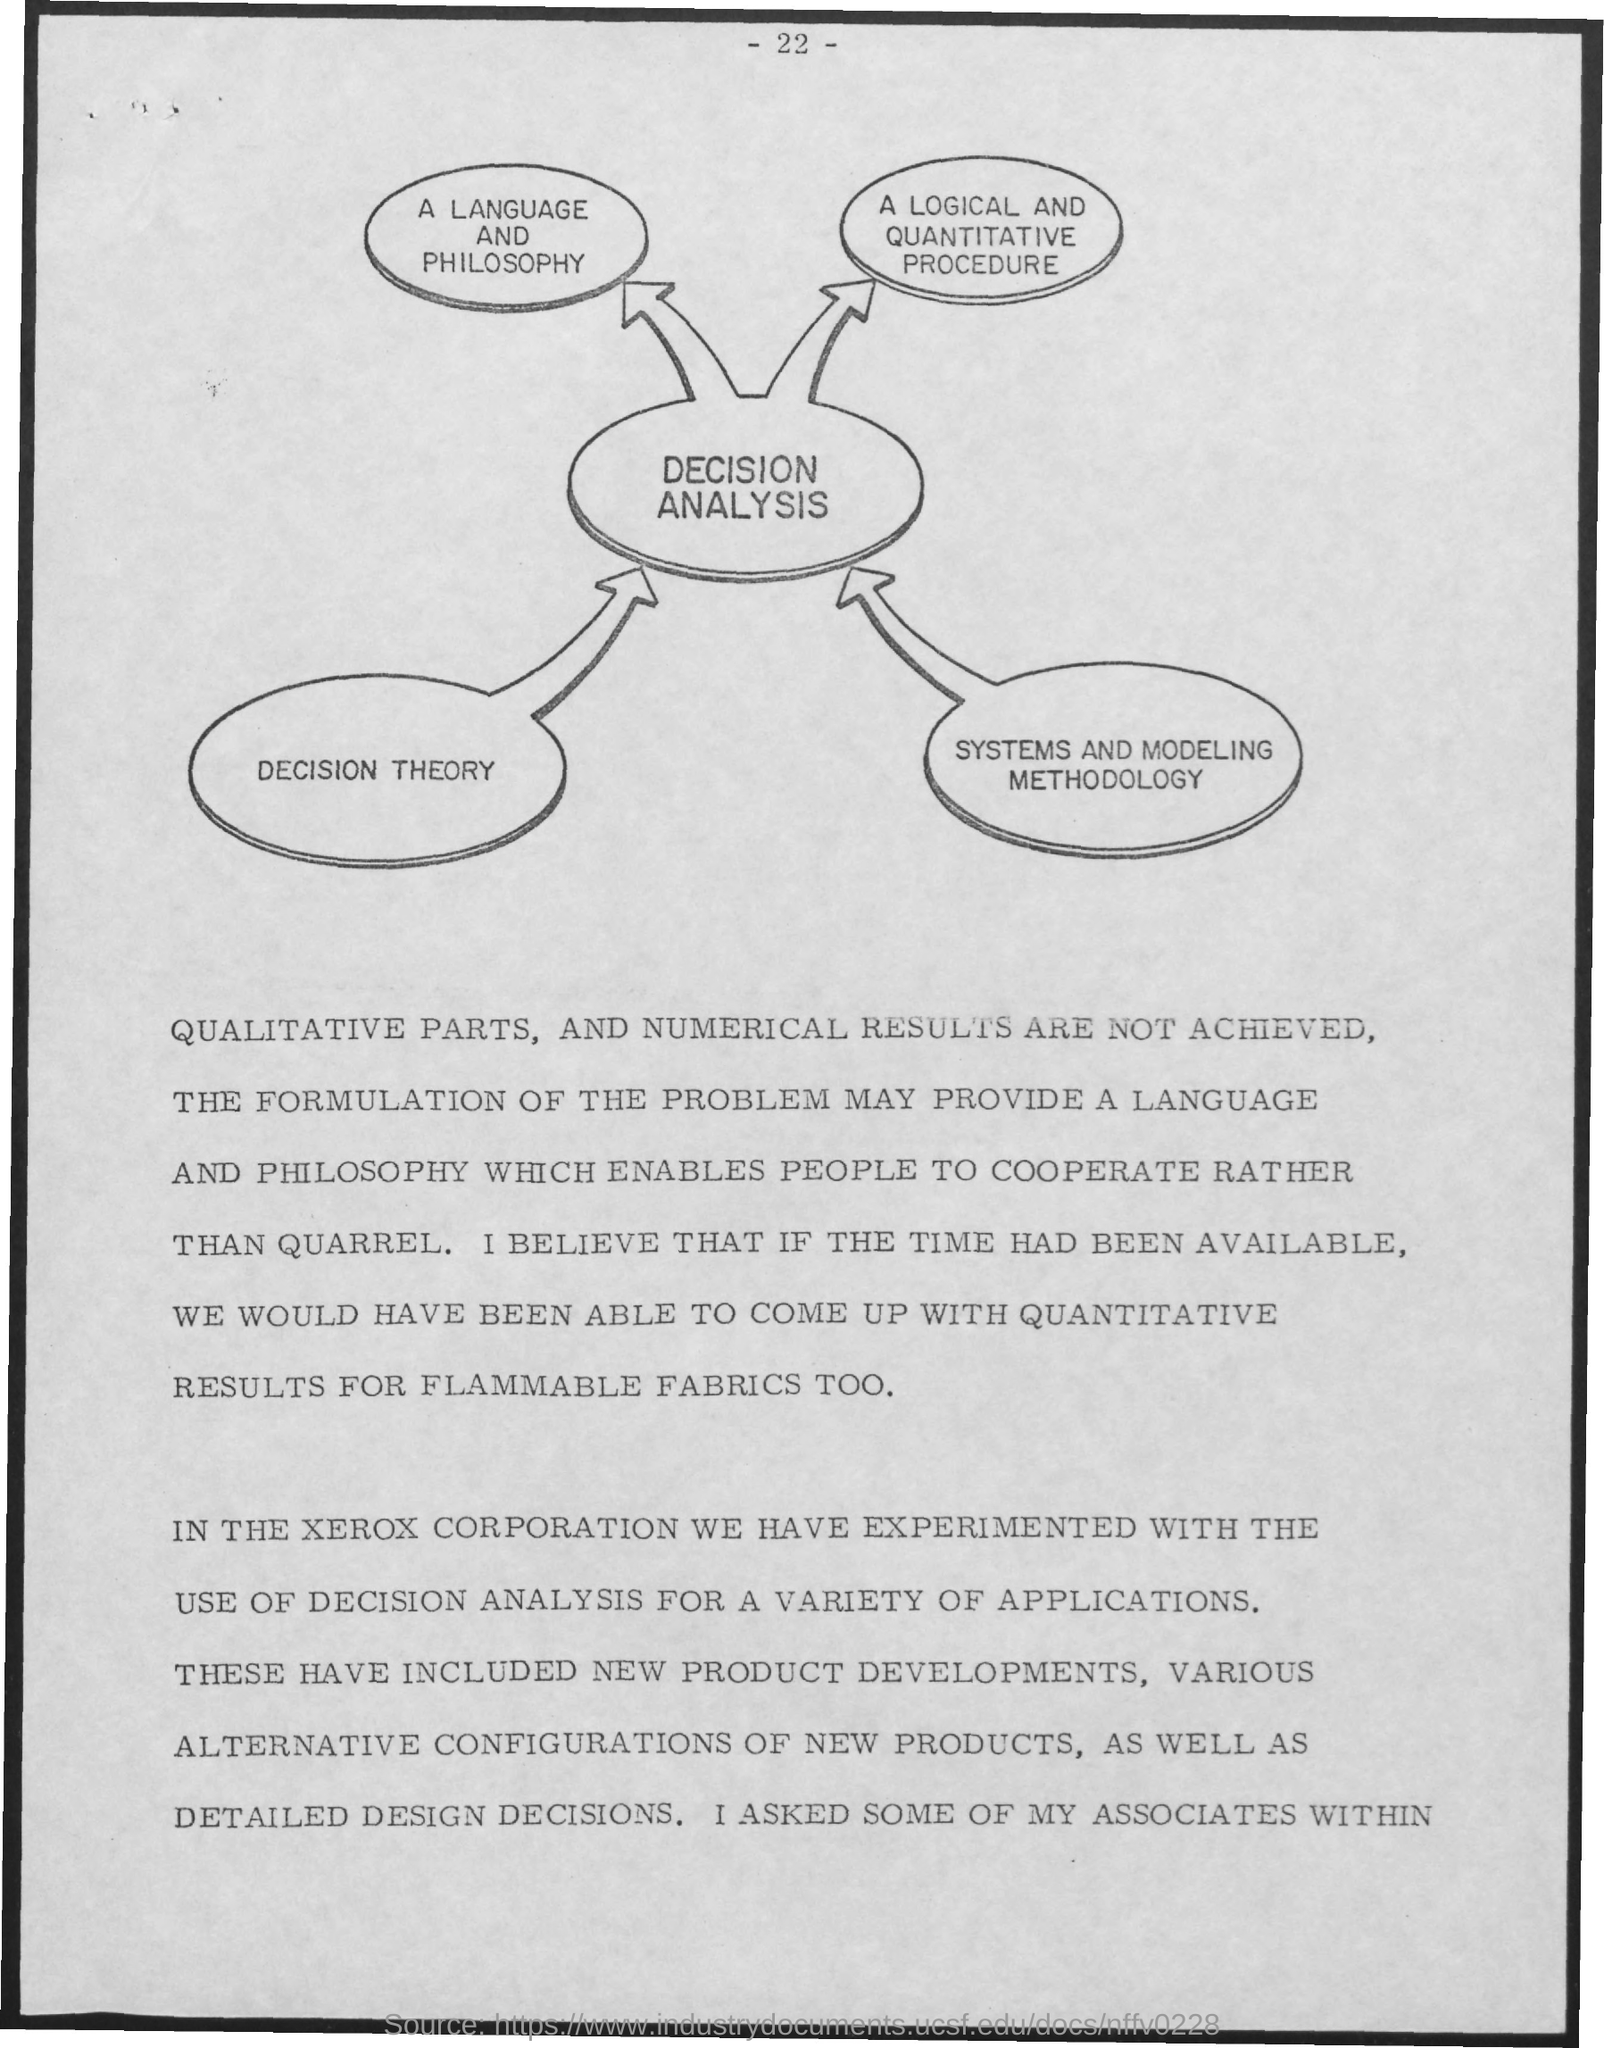What is the Page Number?
Your response must be concise. -22-. 